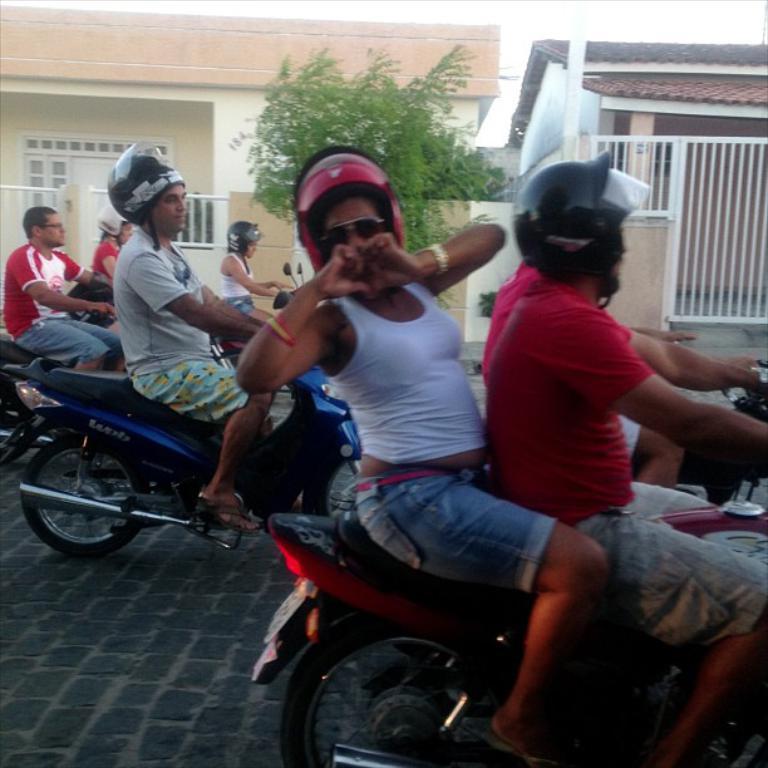In one or two sentences, can you explain what this image depicts? In this picture we can see some people wore helmets, goggles riding bikes on road and some are sitting at back of them and in background we can see houses, fence, trees, door. 